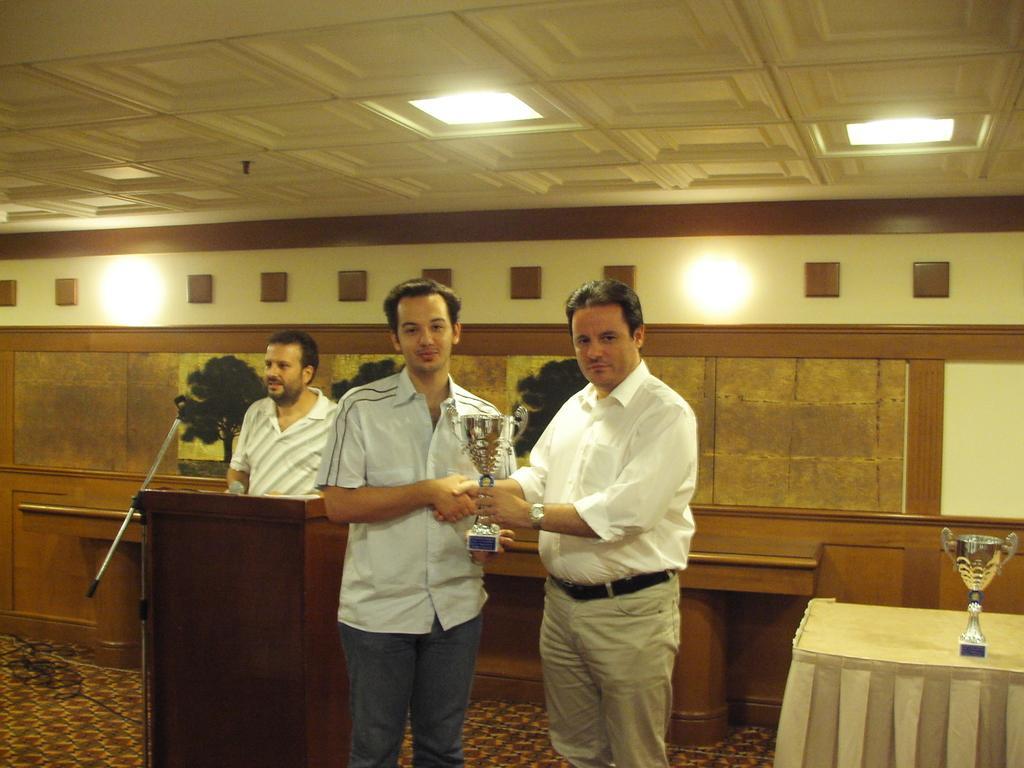Describe this image in one or two sentences. Here a man is standing and giving a prize cup to this man. He wore a white color shirt, in the left side another man is standing near the podium. At the top there are lights. 